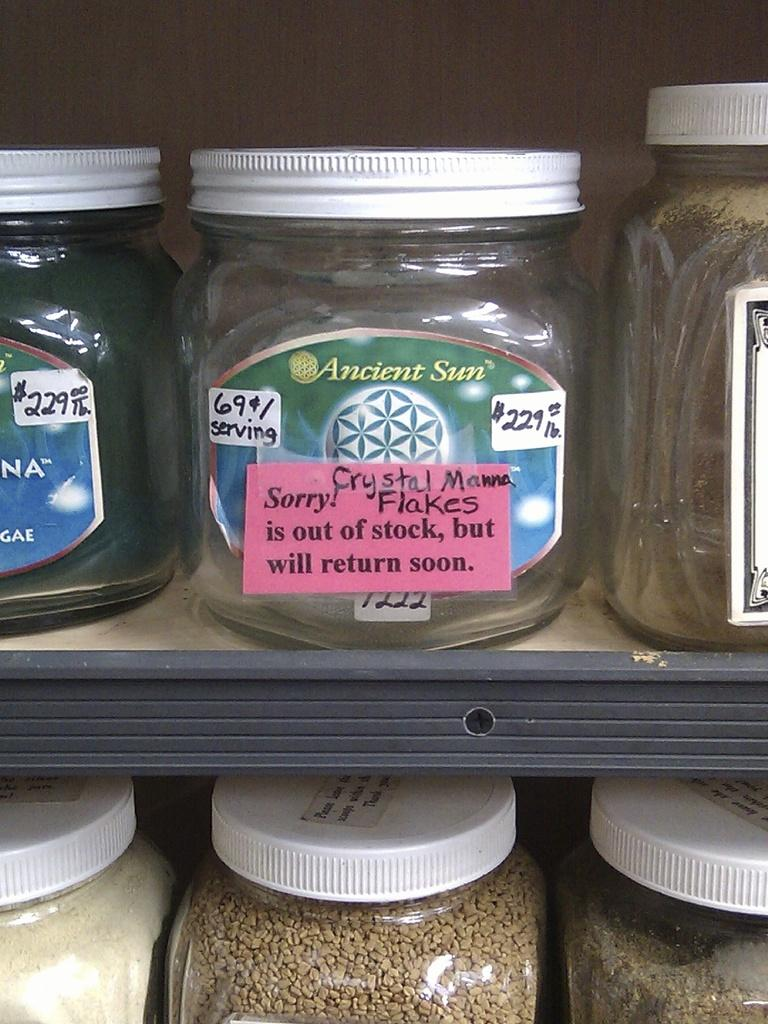<image>
Give a short and clear explanation of the subsequent image. A jar of Ancient sun is on a store shelf. 